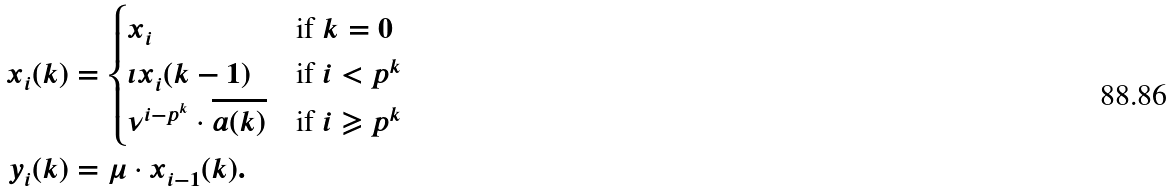Convert formula to latex. <formula><loc_0><loc_0><loc_500><loc_500>x _ { i } ( k ) & = \begin{cases} x _ { i } & \text {if} \ k = 0 \\ \iota x _ { i } ( k - 1 ) & \text {if} \ i < p ^ { k } \\ \nu ^ { i - p ^ { k } } \cdot \overline { a ( k ) } & \text {if} \ i \geqslant p ^ { k } \end{cases} \\ y _ { i } ( k ) & = \mu \cdot x _ { i - 1 } ( k ) .</formula> 